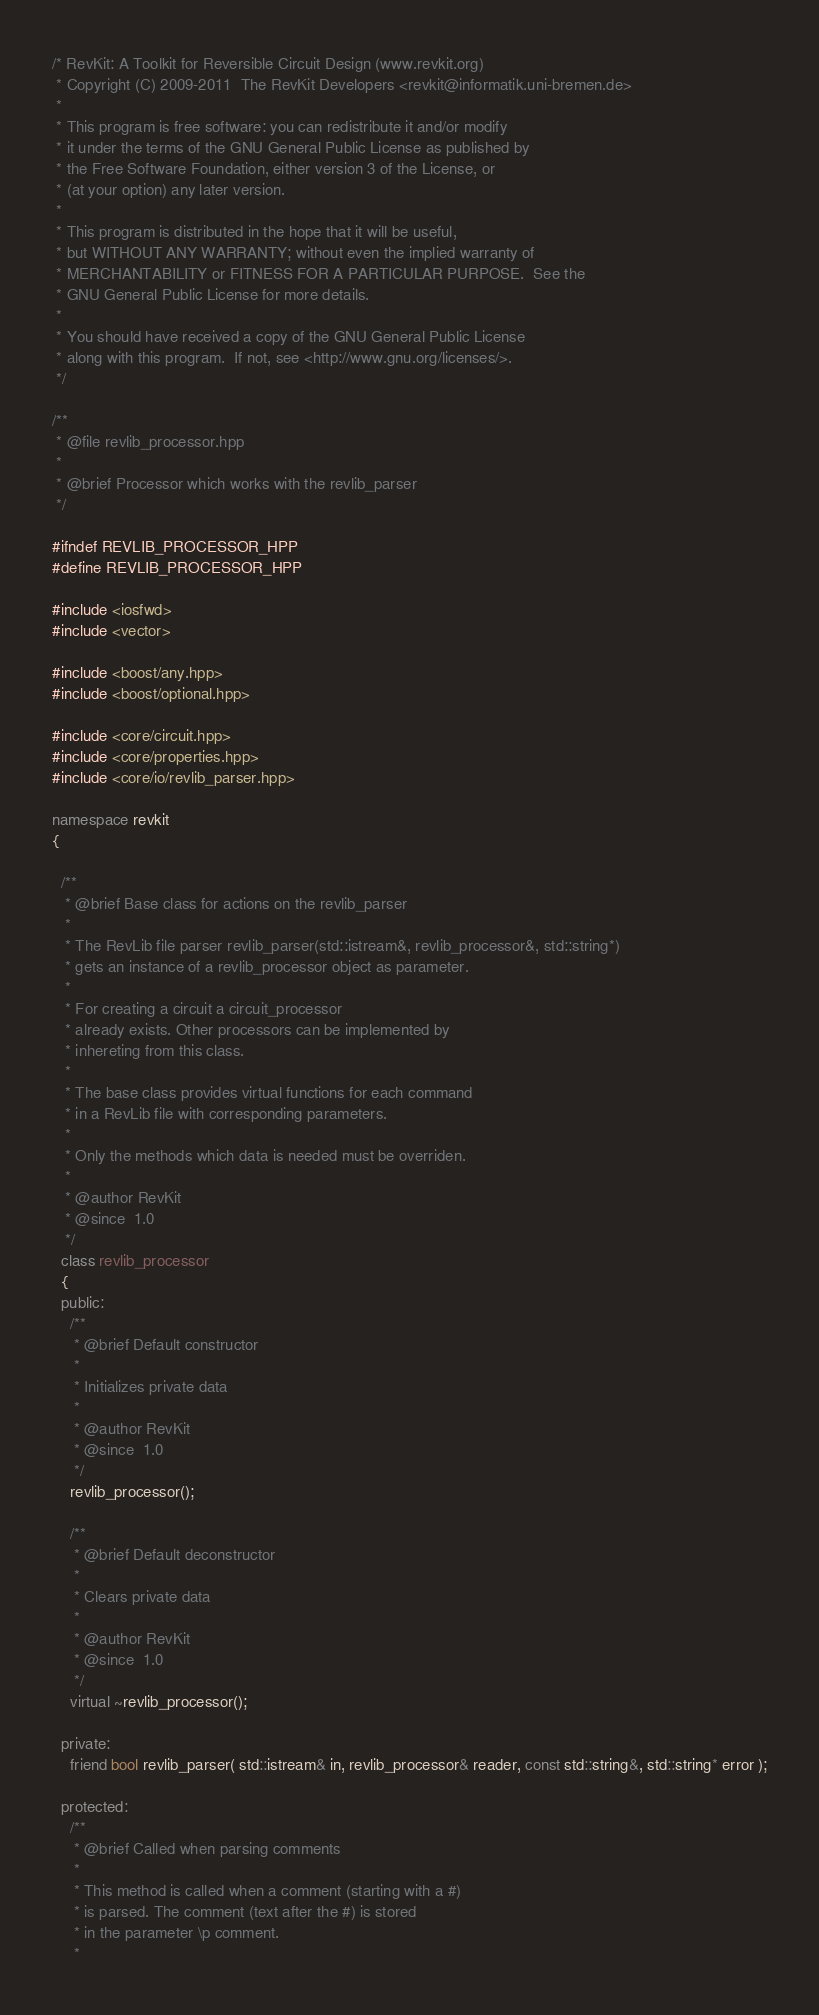<code> <loc_0><loc_0><loc_500><loc_500><_C++_>/* RevKit: A Toolkit for Reversible Circuit Design (www.revkit.org)
 * Copyright (C) 2009-2011  The RevKit Developers <revkit@informatik.uni-bremen.de>
 *
 * This program is free software: you can redistribute it and/or modify
 * it under the terms of the GNU General Public License as published by
 * the Free Software Foundation, either version 3 of the License, or
 * (at your option) any later version.
 *
 * This program is distributed in the hope that it will be useful,
 * but WITHOUT ANY WARRANTY; without even the implied warranty of
 * MERCHANTABILITY or FITNESS FOR A PARTICULAR PURPOSE.  See the
 * GNU General Public License for more details.
 *
 * You should have received a copy of the GNU General Public License
 * along with this program.  If not, see <http://www.gnu.org/licenses/>.
 */

/**
 * @file revlib_processor.hpp
 *
 * @brief Processor which works with the revlib_parser
 */

#ifndef REVLIB_PROCESSOR_HPP
#define REVLIB_PROCESSOR_HPP

#include <iosfwd>
#include <vector>

#include <boost/any.hpp>
#include <boost/optional.hpp>

#include <core/circuit.hpp>
#include <core/properties.hpp>
#include <core/io/revlib_parser.hpp>

namespace revkit
{

  /**
   * @brief Base class for actions on the revlib_parser
   *
   * The RevLib file parser revlib_parser(std::istream&, revlib_processor&, std::string*)
   * gets an instance of a revlib_processor object as parameter.
   *
   * For creating a circuit a circuit_processor
   * already exists. Other processors can be implemented by
   * inhereting from this class.
   *
   * The base class provides virtual functions for each command
   * in a RevLib file with corresponding parameters.
   *
   * Only the methods which data is needed must be overriden.
   *
   * @author RevKit
   * @since  1.0
   */
  class revlib_processor
  {
  public:
    /**
     * @brief Default constructor
     *
     * Initializes private data
     *
     * @author RevKit
     * @since  1.0
     */
    revlib_processor();

    /**
     * @brief Default deconstructor
     *
     * Clears private data
     *
     * @author RevKit
     * @since  1.0
     */
    virtual ~revlib_processor();

  private:
    friend bool revlib_parser( std::istream& in, revlib_processor& reader, const std::string&, std::string* error );

  protected:
    /**
     * @brief Called when parsing comments
     *
     * This method is called when a comment (starting with a #)
     * is parsed. The comment (text after the #) is stored
     * in the parameter \p comment.
     *</code> 